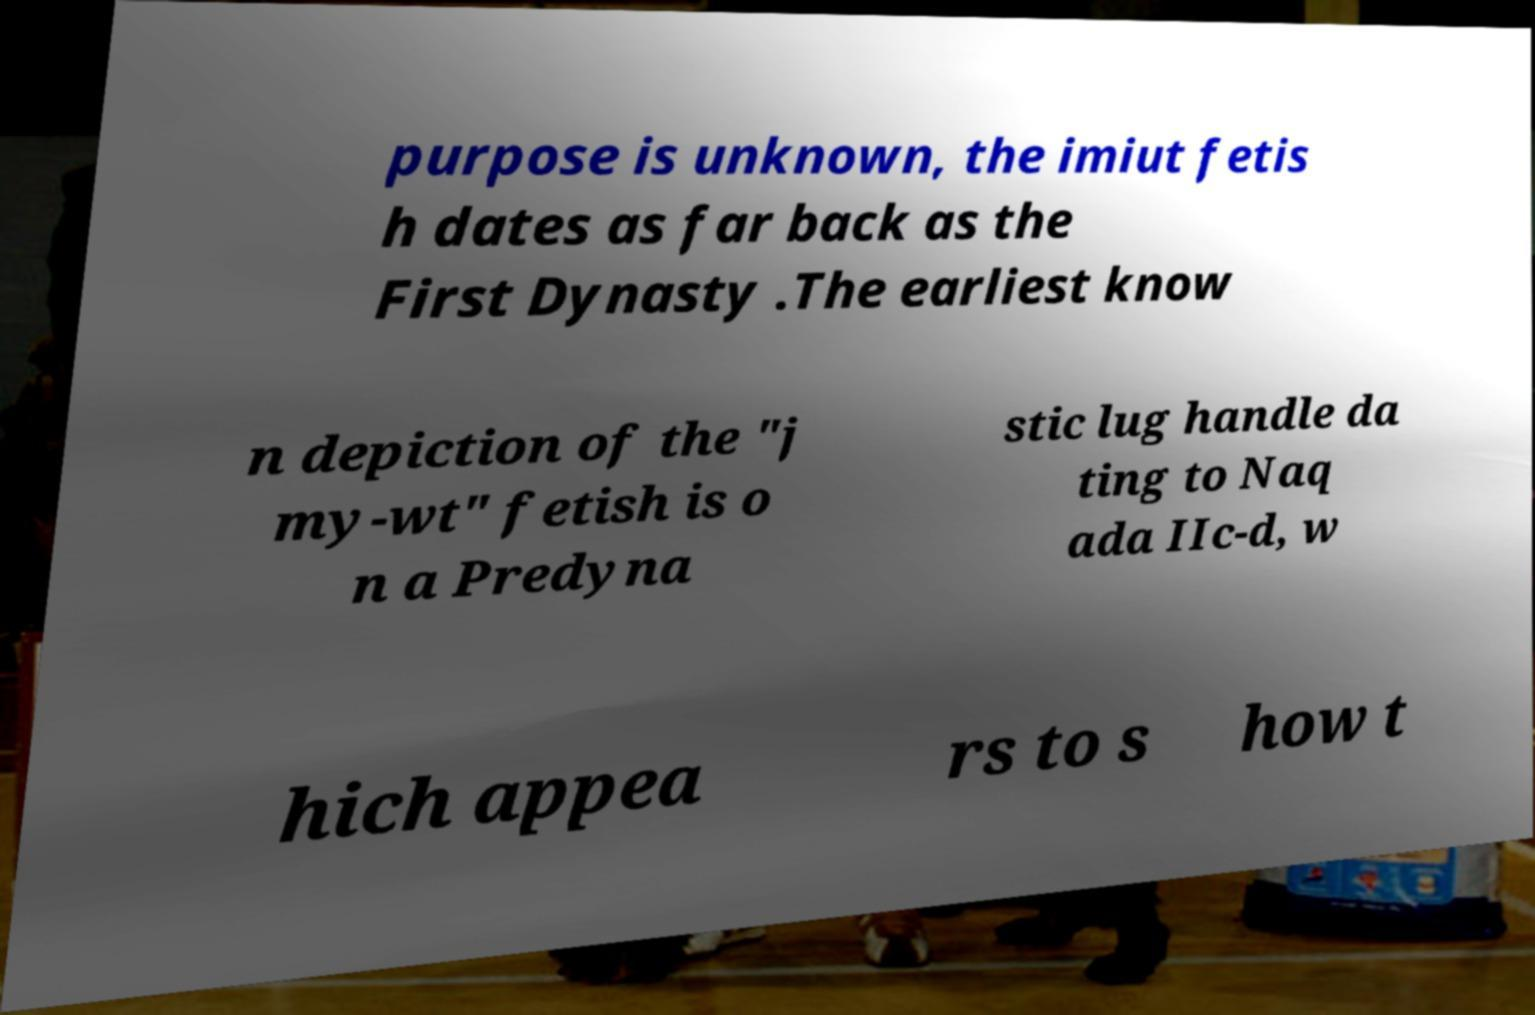What messages or text are displayed in this image? I need them in a readable, typed format. purpose is unknown, the imiut fetis h dates as far back as the First Dynasty .The earliest know n depiction of the "j my-wt" fetish is o n a Predyna stic lug handle da ting to Naq ada IIc-d, w hich appea rs to s how t 